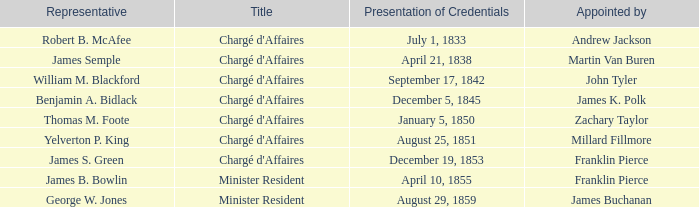Which Title has an Appointed by of Millard Fillmore? Chargé d'Affaires. 